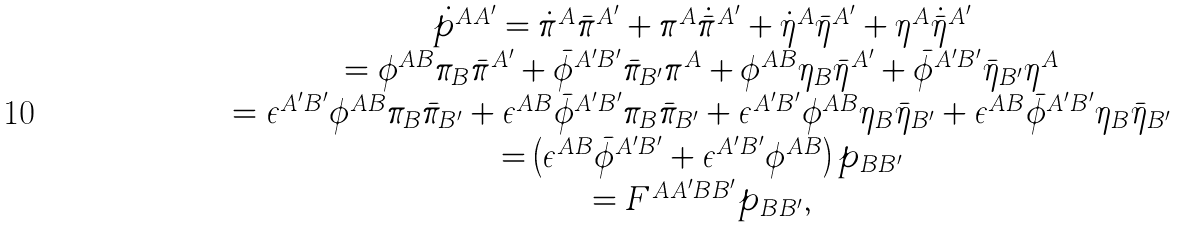<formula> <loc_0><loc_0><loc_500><loc_500>\begin{array} { c } \dot { p } ^ { A A ^ { \prime } } = \dot { \pi } ^ { A } \bar { \pi } ^ { A ^ { \prime } } + \pi ^ { A } \dot { \bar { \pi } } ^ { A ^ { \prime } } + \dot { \eta } ^ { A } \bar { \eta } ^ { A ^ { \prime } } + \eta ^ { A } \dot { \bar { \eta } } ^ { A ^ { \prime } } \\ = \phi ^ { A B } \pi _ { B } \bar { \pi } ^ { A ^ { \prime } } + \bar { \phi } ^ { A ^ { \prime } B ^ { \prime } } \bar { \pi } _ { B ^ { \prime } } \pi ^ { A } + \phi ^ { A B } \eta _ { B } \bar { \eta } ^ { A ^ { \prime } } + \bar { \phi } ^ { A ^ { \prime } B ^ { \prime } } \bar { \eta } _ { B ^ { \prime } } \eta ^ { A } \\ = \epsilon ^ { A ^ { \prime } B ^ { \prime } } \phi ^ { A B } \pi _ { B } \bar { \pi } _ { B ^ { \prime } } + \epsilon ^ { A B } \bar { \phi } ^ { A ^ { \prime } B ^ { \prime } } \pi _ { B } \bar { \pi } _ { B ^ { \prime } } + \epsilon ^ { A ^ { \prime } B ^ { \prime } } \phi ^ { A B } \eta _ { B } \bar { \eta } _ { B ^ { \prime } } + \epsilon ^ { A B } \bar { \phi } ^ { A ^ { \prime } B ^ { \prime } } \eta _ { B } \bar { \eta } _ { B ^ { \prime } } \\ = \left ( \epsilon ^ { A B } \bar { \phi } ^ { A ^ { \prime } B ^ { \prime } } + \epsilon ^ { A ^ { \prime } B ^ { \prime } } \phi ^ { A B } \right ) p _ { B B ^ { \prime } } \\ = F ^ { A A ^ { \prime } B B ^ { \prime } } p _ { B B ^ { \prime } } , \end{array}</formula> 